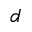Convert formula to latex. <formula><loc_0><loc_0><loc_500><loc_500>d</formula> 